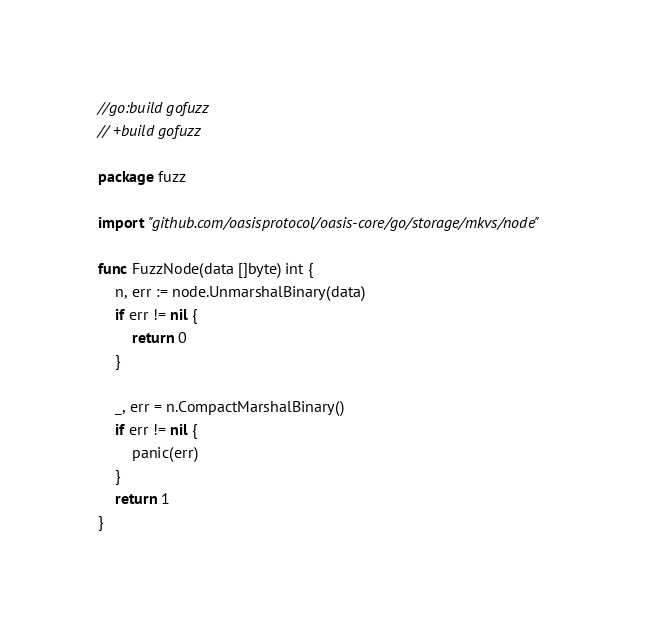Convert code to text. <code><loc_0><loc_0><loc_500><loc_500><_Go_>//go:build gofuzz
// +build gofuzz

package fuzz

import "github.com/oasisprotocol/oasis-core/go/storage/mkvs/node"

func FuzzNode(data []byte) int {
	n, err := node.UnmarshalBinary(data)
	if err != nil {
		return 0
	}

	_, err = n.CompactMarshalBinary()
	if err != nil {
		panic(err)
	}
	return 1
}
</code> 